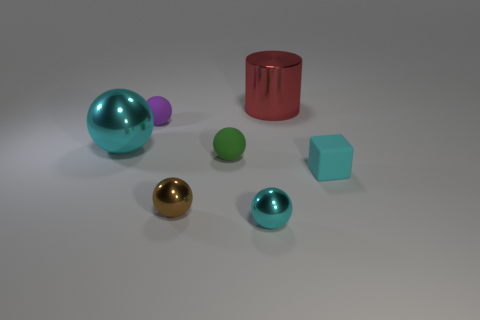Subtract all large balls. How many balls are left? 4 Subtract all brown spheres. How many spheres are left? 4 Subtract all gray spheres. Subtract all brown cylinders. How many spheres are left? 5 Add 3 cyan metal things. How many objects exist? 10 Subtract all cylinders. How many objects are left? 6 Add 7 tiny purple rubber balls. How many tiny purple rubber balls exist? 8 Subtract 1 green balls. How many objects are left? 6 Subtract all small purple blocks. Subtract all large cylinders. How many objects are left? 6 Add 5 big red metal things. How many big red metal things are left? 6 